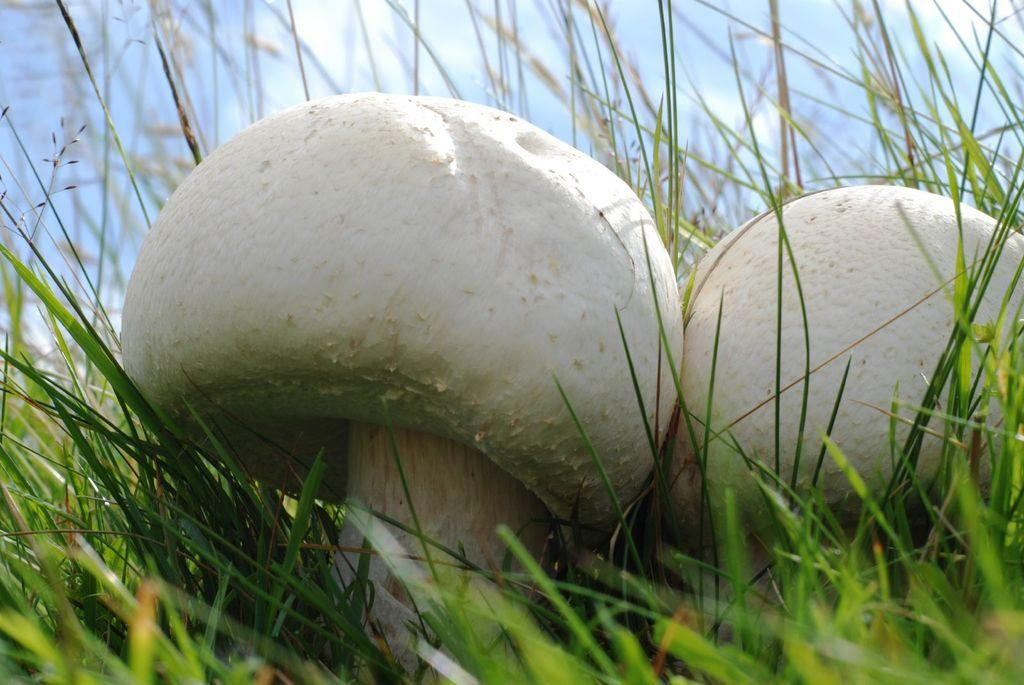What type of vegetation can be seen in the image? There are mushrooms in the image. What is on the ground in the image? There is grass on the ground in the image. What can be seen in the background of the image? The sky is visible in the background of the image. What type of engine can be seen powering the mushrooms in the image? There is no engine present in the image, and mushrooms do not require engines to grow or function. 